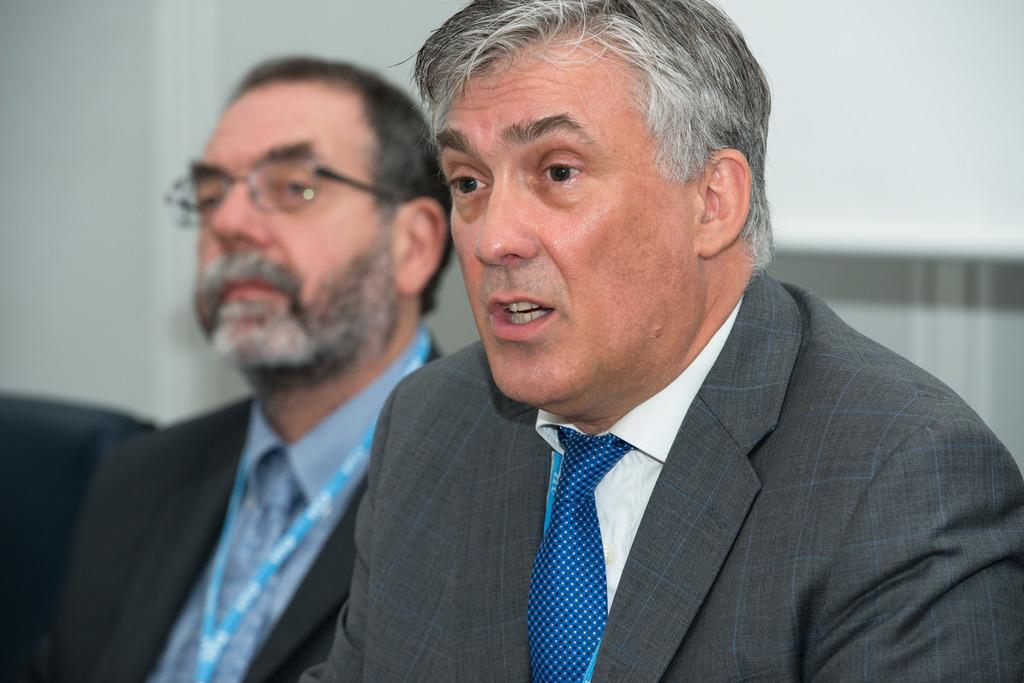How many people are present in the image? There are two persons in the image. What can be seen in the background of the image? There is a wall in the background of the image. Where is the chair located in the image? The chair is on the left side of the image. What type of engine can be seen powering the cave in the image? There is no engine or cave present in the image. 